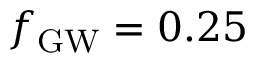<formula> <loc_0><loc_0><loc_500><loc_500>{ f _ { G W } } = 0 . 2 5</formula> 